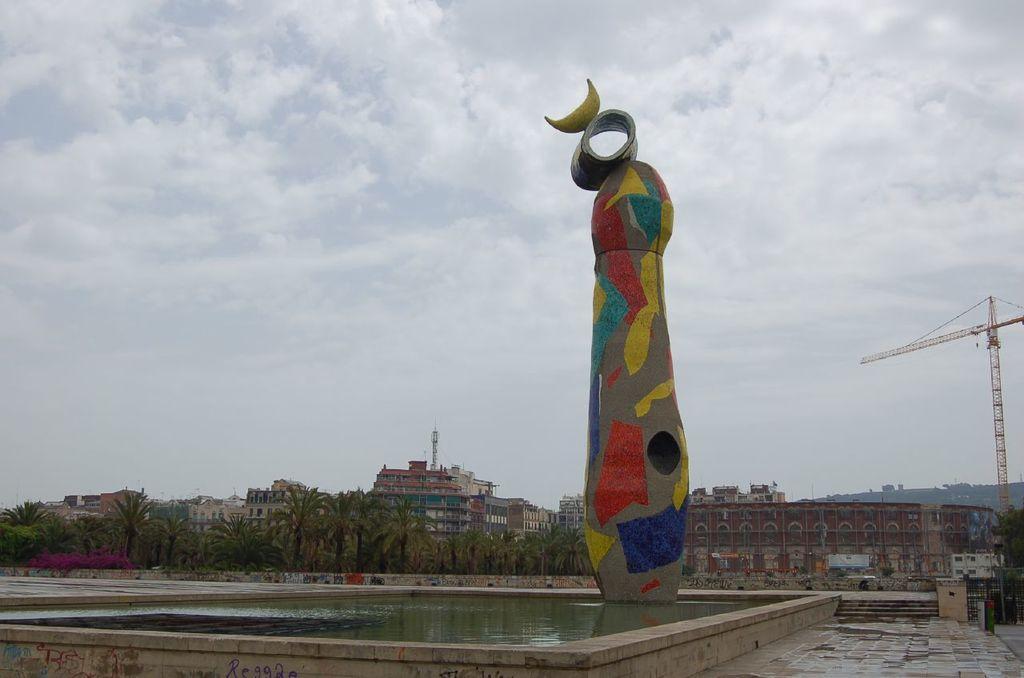Could you give a brief overview of what you see in this image? In the middle of the picture, we see the sculpture. Beside that, we see water and this water might be in the pool. In the right bottom, we see the pavement and the staircase. On the right side, we see a tower. There are trees, buildings and a tower in the background. At the top, we see the sky and the clouds. 